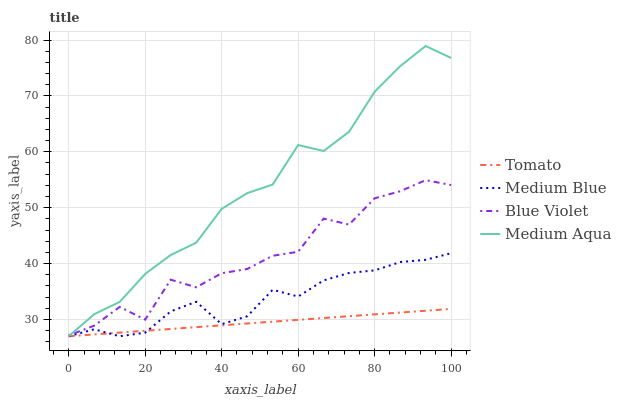Does Tomato have the minimum area under the curve?
Answer yes or no. Yes. Does Medium Aqua have the maximum area under the curve?
Answer yes or no. Yes. Does Medium Blue have the minimum area under the curve?
Answer yes or no. No. Does Medium Blue have the maximum area under the curve?
Answer yes or no. No. Is Tomato the smoothest?
Answer yes or no. Yes. Is Blue Violet the roughest?
Answer yes or no. Yes. Is Medium Aqua the smoothest?
Answer yes or no. No. Is Medium Aqua the roughest?
Answer yes or no. No. Does Tomato have the lowest value?
Answer yes or no. Yes. Does Blue Violet have the lowest value?
Answer yes or no. No. Does Medium Aqua have the highest value?
Answer yes or no. Yes. Does Medium Blue have the highest value?
Answer yes or no. No. Is Tomato less than Blue Violet?
Answer yes or no. Yes. Is Blue Violet greater than Tomato?
Answer yes or no. Yes. Does Medium Aqua intersect Tomato?
Answer yes or no. Yes. Is Medium Aqua less than Tomato?
Answer yes or no. No. Is Medium Aqua greater than Tomato?
Answer yes or no. No. Does Tomato intersect Blue Violet?
Answer yes or no. No. 